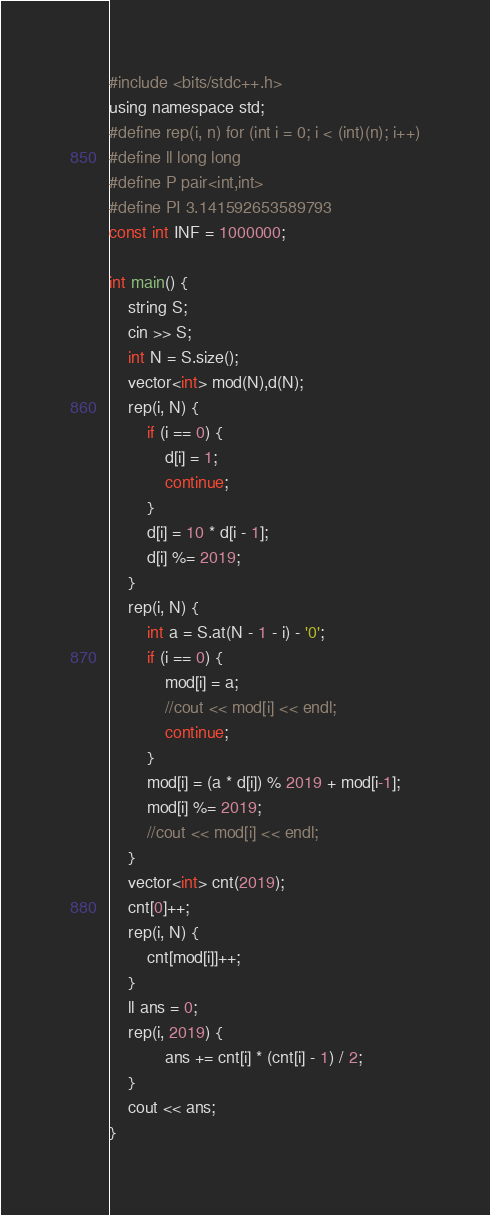<code> <loc_0><loc_0><loc_500><loc_500><_C_>#include <bits/stdc++.h>
using namespace std;
#define rep(i, n) for (int i = 0; i < (int)(n); i++)
#define ll long long
#define P pair<int,int>
#define PI 3.141592653589793
const int INF = 1000000;

int main() {
	string S;
	cin >> S;
	int N = S.size();
	vector<int> mod(N),d(N);
	rep(i, N) {
		if (i == 0) {
			d[i] = 1;
			continue;
		}
		d[i] = 10 * d[i - 1];
		d[i] %= 2019;
	}
	rep(i, N) {
		int a = S.at(N - 1 - i) - '0';
		if (i == 0) {
			mod[i] = a;
			//cout << mod[i] << endl;
			continue;
		}
		mod[i] = (a * d[i]) % 2019 + mod[i-1];
		mod[i] %= 2019;
		//cout << mod[i] << endl;
	}
	vector<int> cnt(2019);
	cnt[0]++;
	rep(i, N) {
		cnt[mod[i]]++;
	}
	ll ans = 0;
	rep(i, 2019) {
			ans += cnt[i] * (cnt[i] - 1) / 2;
	}
	cout << ans;
}
</code> 